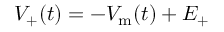Convert formula to latex. <formula><loc_0><loc_0><loc_500><loc_500>V _ { + } ( t ) = - V _ { m } ( t ) + E _ { + }</formula> 